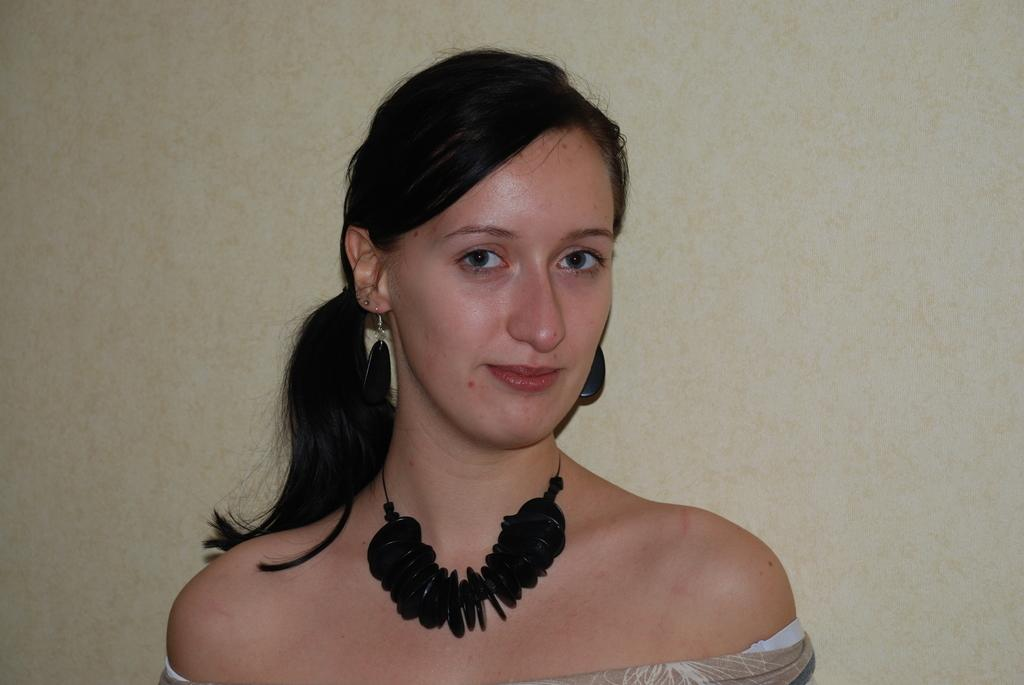What is the main subject of the image? The main subject of the image is a woman. What can be seen in the background of the image? There is a wall in the background of the image. What type of canvas is the woman painting in the image? There is no canvas present in the image, and the woman is not depicted as painting. What is the height of the railway in the image? There is no railway present in the image. 